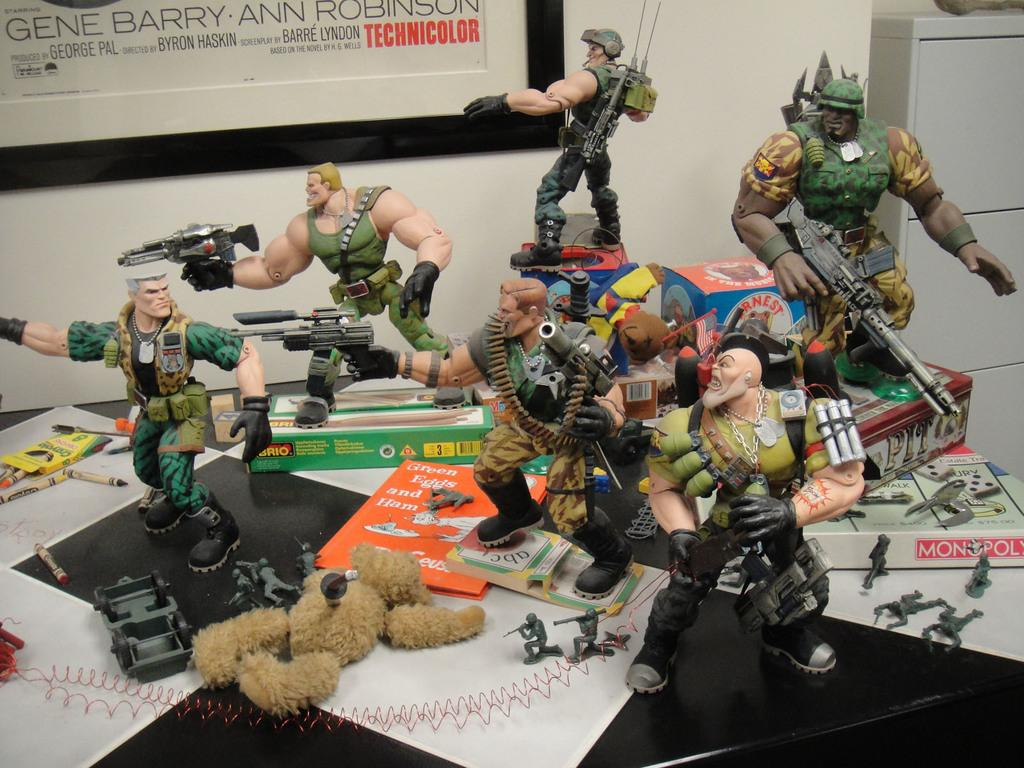What type of toys are depicted in the image? The toys in the image are of men holding weapons. Can you describe any other objects or figures in the image? Yes, there is a teddy bear on the floor in the image. What type of spark can be seen coming from the son's rifle in the image? There is no son or rifle present in the image; it features toys of men holding weapons and a teddy bear on the floor. 